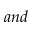Convert formula to latex. <formula><loc_0><loc_0><loc_500><loc_500>a n d</formula> 